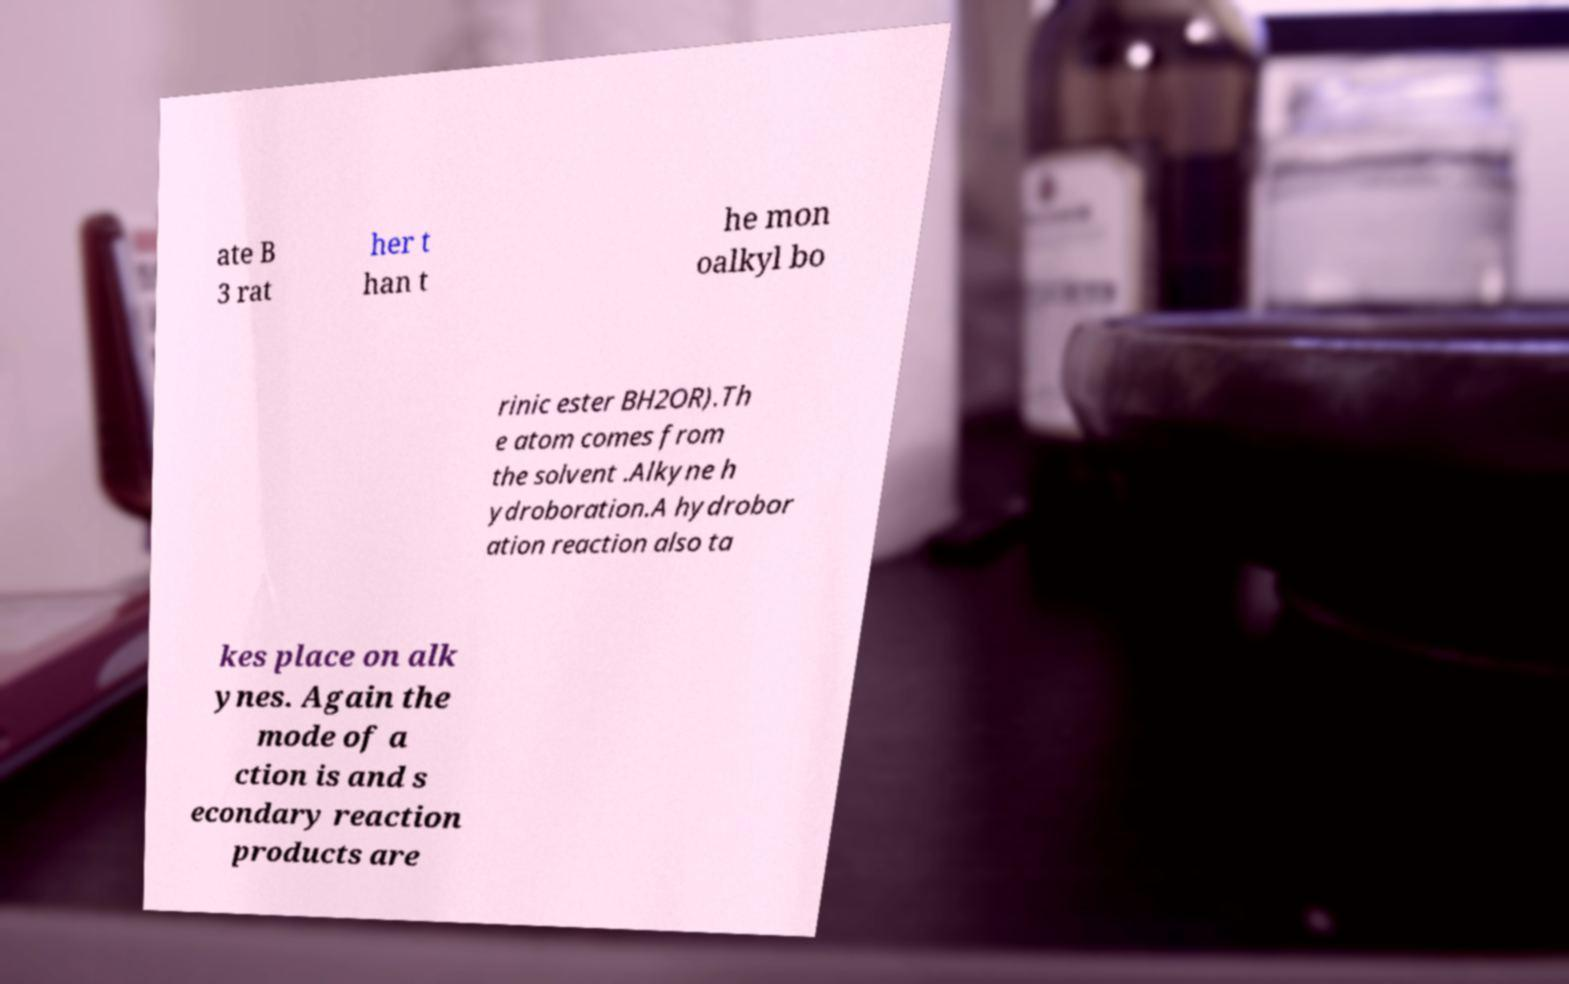I need the written content from this picture converted into text. Can you do that? ate B 3 rat her t han t he mon oalkyl bo rinic ester BH2OR).Th e atom comes from the solvent .Alkyne h ydroboration.A hydrobor ation reaction also ta kes place on alk ynes. Again the mode of a ction is and s econdary reaction products are 